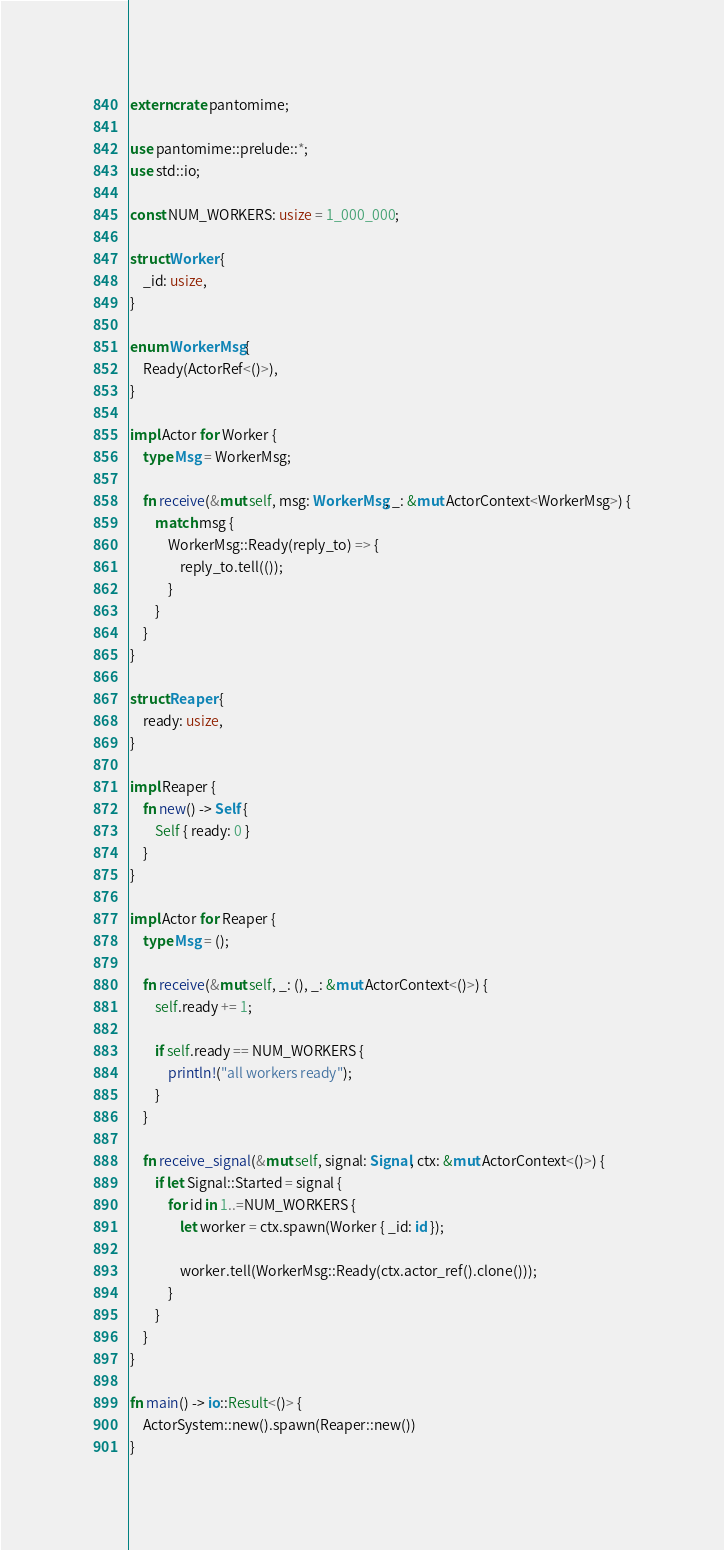<code> <loc_0><loc_0><loc_500><loc_500><_Rust_>extern crate pantomime;

use pantomime::prelude::*;
use std::io;

const NUM_WORKERS: usize = 1_000_000;

struct Worker {
    _id: usize,
}

enum WorkerMsg {
    Ready(ActorRef<()>),
}

impl Actor for Worker {
    type Msg = WorkerMsg;

    fn receive(&mut self, msg: WorkerMsg, _: &mut ActorContext<WorkerMsg>) {
        match msg {
            WorkerMsg::Ready(reply_to) => {
                reply_to.tell(());
            }
        }
    }
}

struct Reaper {
    ready: usize,
}

impl Reaper {
    fn new() -> Self {
        Self { ready: 0 }
    }
}

impl Actor for Reaper {
    type Msg = ();

    fn receive(&mut self, _: (), _: &mut ActorContext<()>) {
        self.ready += 1;

        if self.ready == NUM_WORKERS {
            println!("all workers ready");
        }
    }

    fn receive_signal(&mut self, signal: Signal, ctx: &mut ActorContext<()>) {
        if let Signal::Started = signal {
            for id in 1..=NUM_WORKERS {
                let worker = ctx.spawn(Worker { _id: id });

                worker.tell(WorkerMsg::Ready(ctx.actor_ref().clone()));
            }
        }
    }
}

fn main() -> io::Result<()> {
    ActorSystem::new().spawn(Reaper::new())
}
</code> 